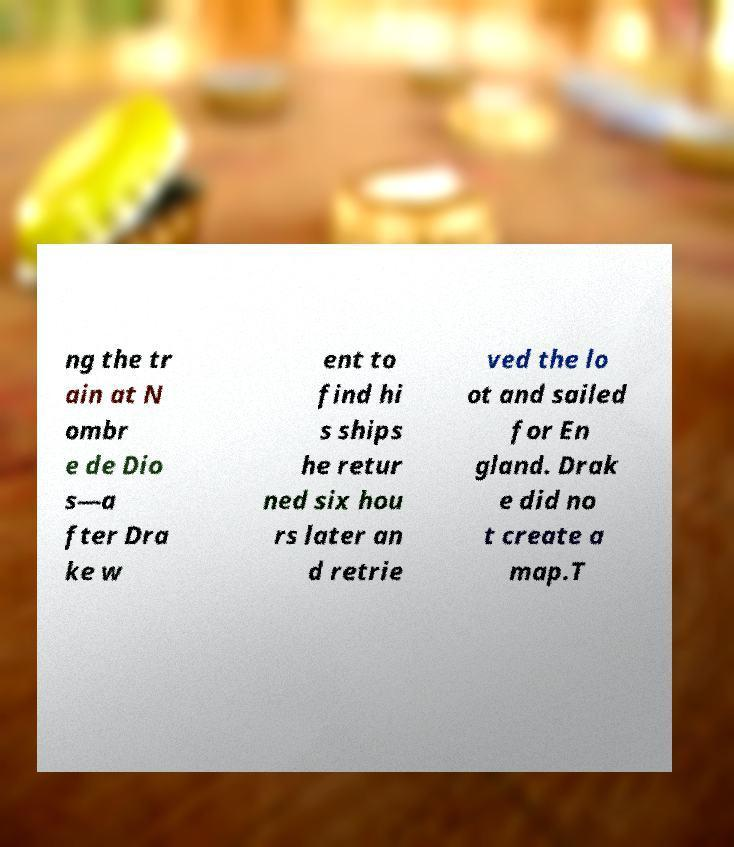Could you assist in decoding the text presented in this image and type it out clearly? ng the tr ain at N ombr e de Dio s—a fter Dra ke w ent to find hi s ships he retur ned six hou rs later an d retrie ved the lo ot and sailed for En gland. Drak e did no t create a map.T 